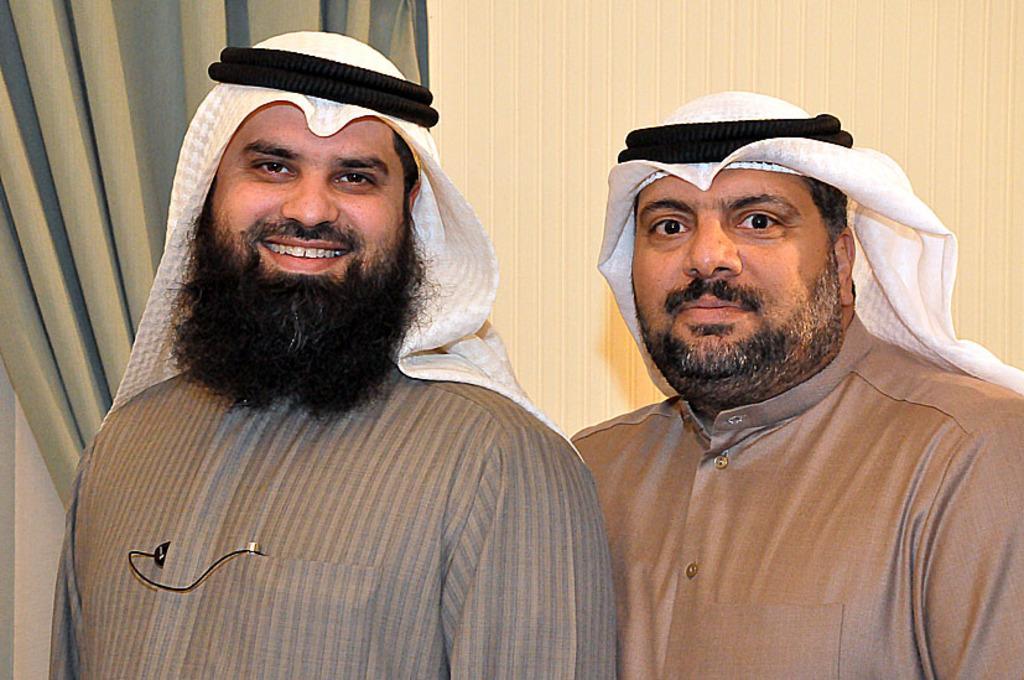Can you describe this image briefly? In this picture we can see two men wore black color round shaped objects on heads with white scarves and smiling and at the back of them we can see the wall and curtains. 